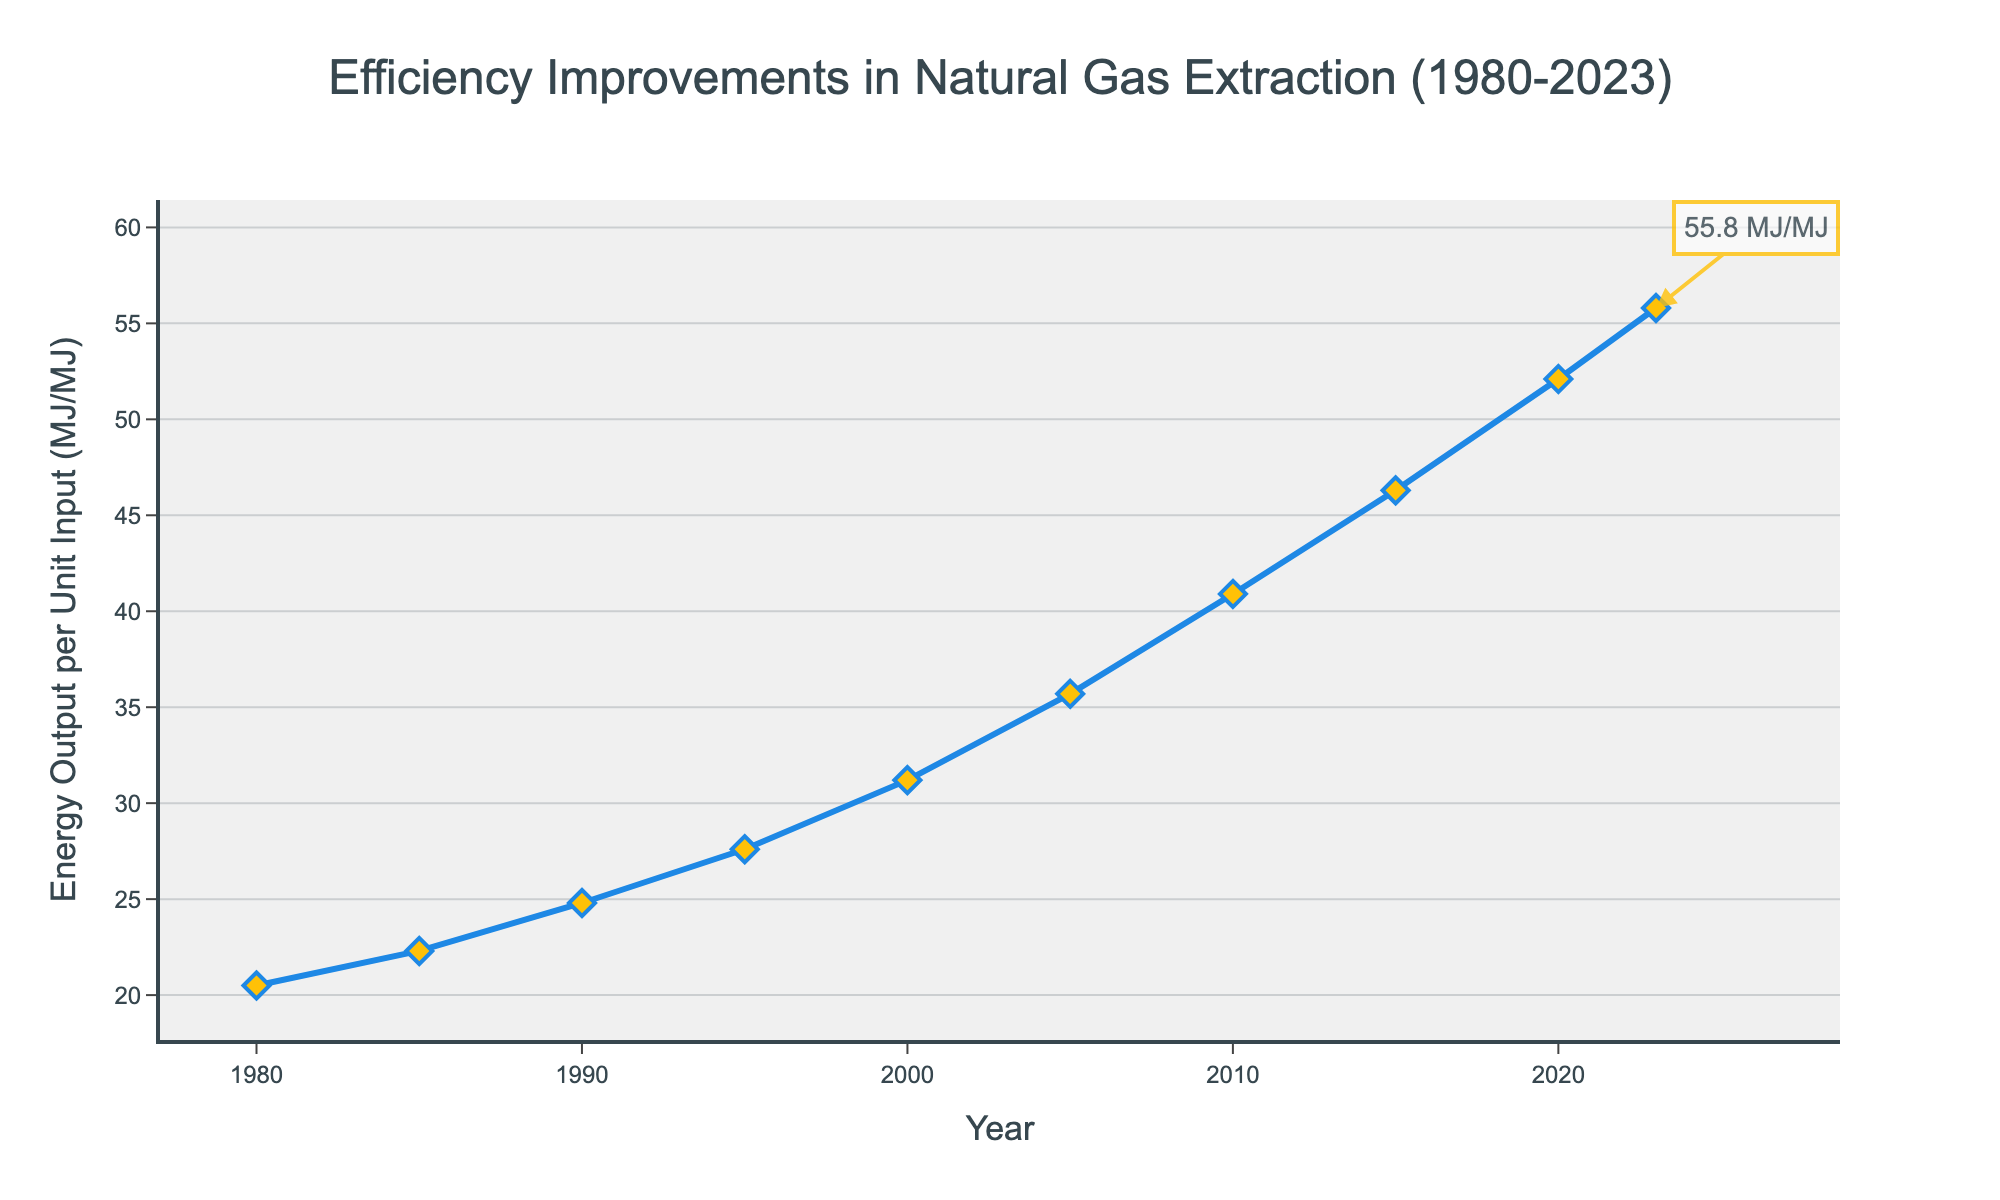What's the energy output per unit input in 1990? First, locate the year 1990 on the x-axis. Then, trace upwards until you reach the line, and read the corresponding y-axis value, which represents the energy output per unit input.
Answer: 24.8 MJ/MJ How much did the energy output per unit input increase from 1980 to 2023? Identify the y-axis values for 1980 and 2023, which are 20.5 MJ/MJ and 55.8 MJ/MJ, respectively. Subtract the 1980 value from the 2023 value: 55.8 - 20.5 = 35.3 MJ/MJ.
Answer: 35.3 MJ/MJ During which period did the energy output per unit input increase the most? Compare the difference in energy output between consecutive years. The largest increase occurred between 2005 (35.7 MJ/MJ) and 2010 (40.9 MJ/MJ). Calculate the difference: 40.9 - 35.7 = 5.2 MJ/MJ. Other differences are smaller.
Answer: 2005 to 2010 What is the average energy output per unit input from 1980 to 2023? Sum all y-axis values and divide by the number of data points. (20.5 + 22.3 + 24.8 + 27.6 + 31.2 + 35.7 + 40.9 + 46.3 + 52.1 + 55.8) / 10. The result is 357.2 / 10 = 35.72 MJ/MJ.
Answer: 35.72 MJ/MJ Which year experienced the smallest increase in energy output per unit input compared to the previous period? Calculate the year-on-year increases and find the smallest increment. Example: 1985 (22.3) - 1980 (20.5) = 1.8 MJ/MJ; 1990 (24.8) - 1985 (22.3) = 2.5 MJ/MJ, etc. The smallest increase is between 1980 and 1985: 1.8 MJ/MJ.
Answer: 1980-1985 Is the increase in energy output per unit input rate accelerating over time? Inspect the slope of the line for each period visually. The line appears to get steeper from 2000 onwards, indicating the rate of increase is indeed accelerating.
Answer: Yes What is the median energy output per unit input between 1980 and 2023? List the data points in ascending order and find the middle value. For an even number of points, average the two middle values. The middle values are 31.2 and 35.7. (31.2 + 35.7) / 2 = 33.45 MJ/MJ.
Answer: 33.45 MJ/MJ What is the color of the line representing the energy output data in the plot? Visually inspect the plot. The color of the line representing energy output data is blue.
Answer: Blue Which year had a higher energy output per unit input: 2000 or 2010? Compare the energy output per unit input for 2000 (31.2 MJ/MJ) and 2010 (40.9 MJ/MJ). 2010 has a higher value.
Answer: 2010 